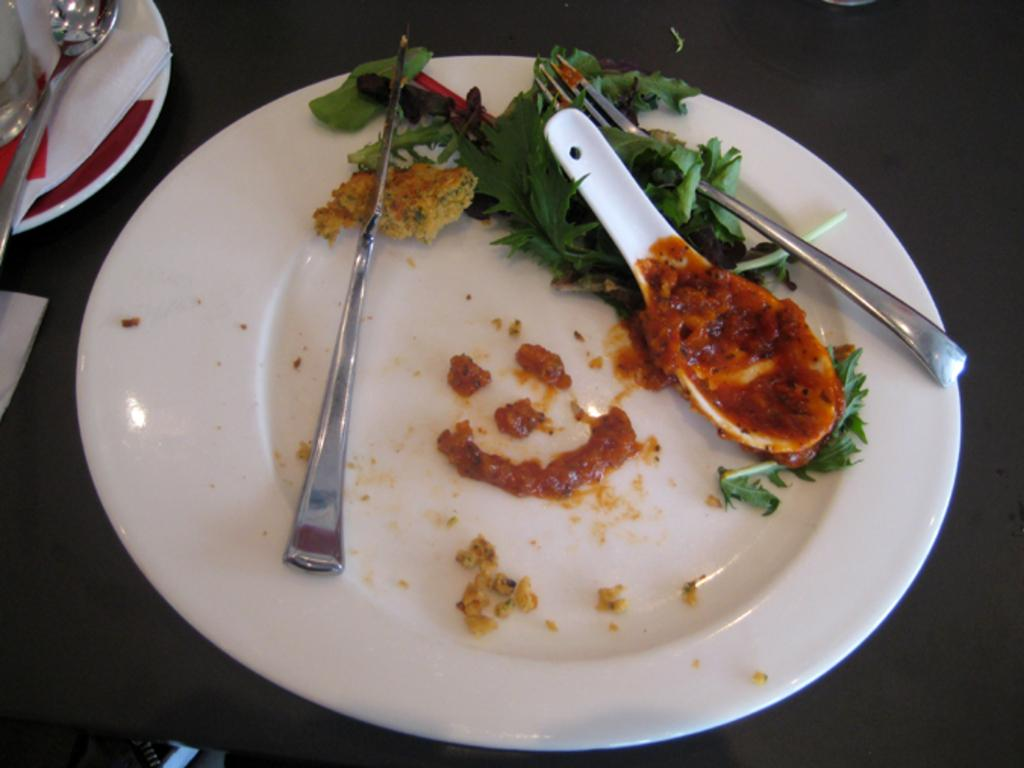What is on the plate in the image? The plate contains a fork, a spoon, leaves, and a knife. What type of utensil is on the plate? There is a spoon on the plate. What else can be seen in the image besides the plate? There are tissue papers in the image. What hobbies are the leaves engaged in during the afternoon in the image? The leaves are not engaged in any hobbies, as they are inanimate objects. Additionally, there is no indication of the time of day in the image. 